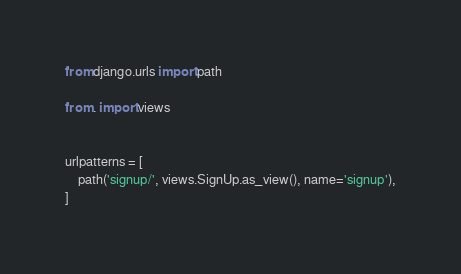<code> <loc_0><loc_0><loc_500><loc_500><_Python_>from django.urls import path

from . import views


urlpatterns = [
    path('signup/', views.SignUp.as_view(), name='signup'),
]</code> 